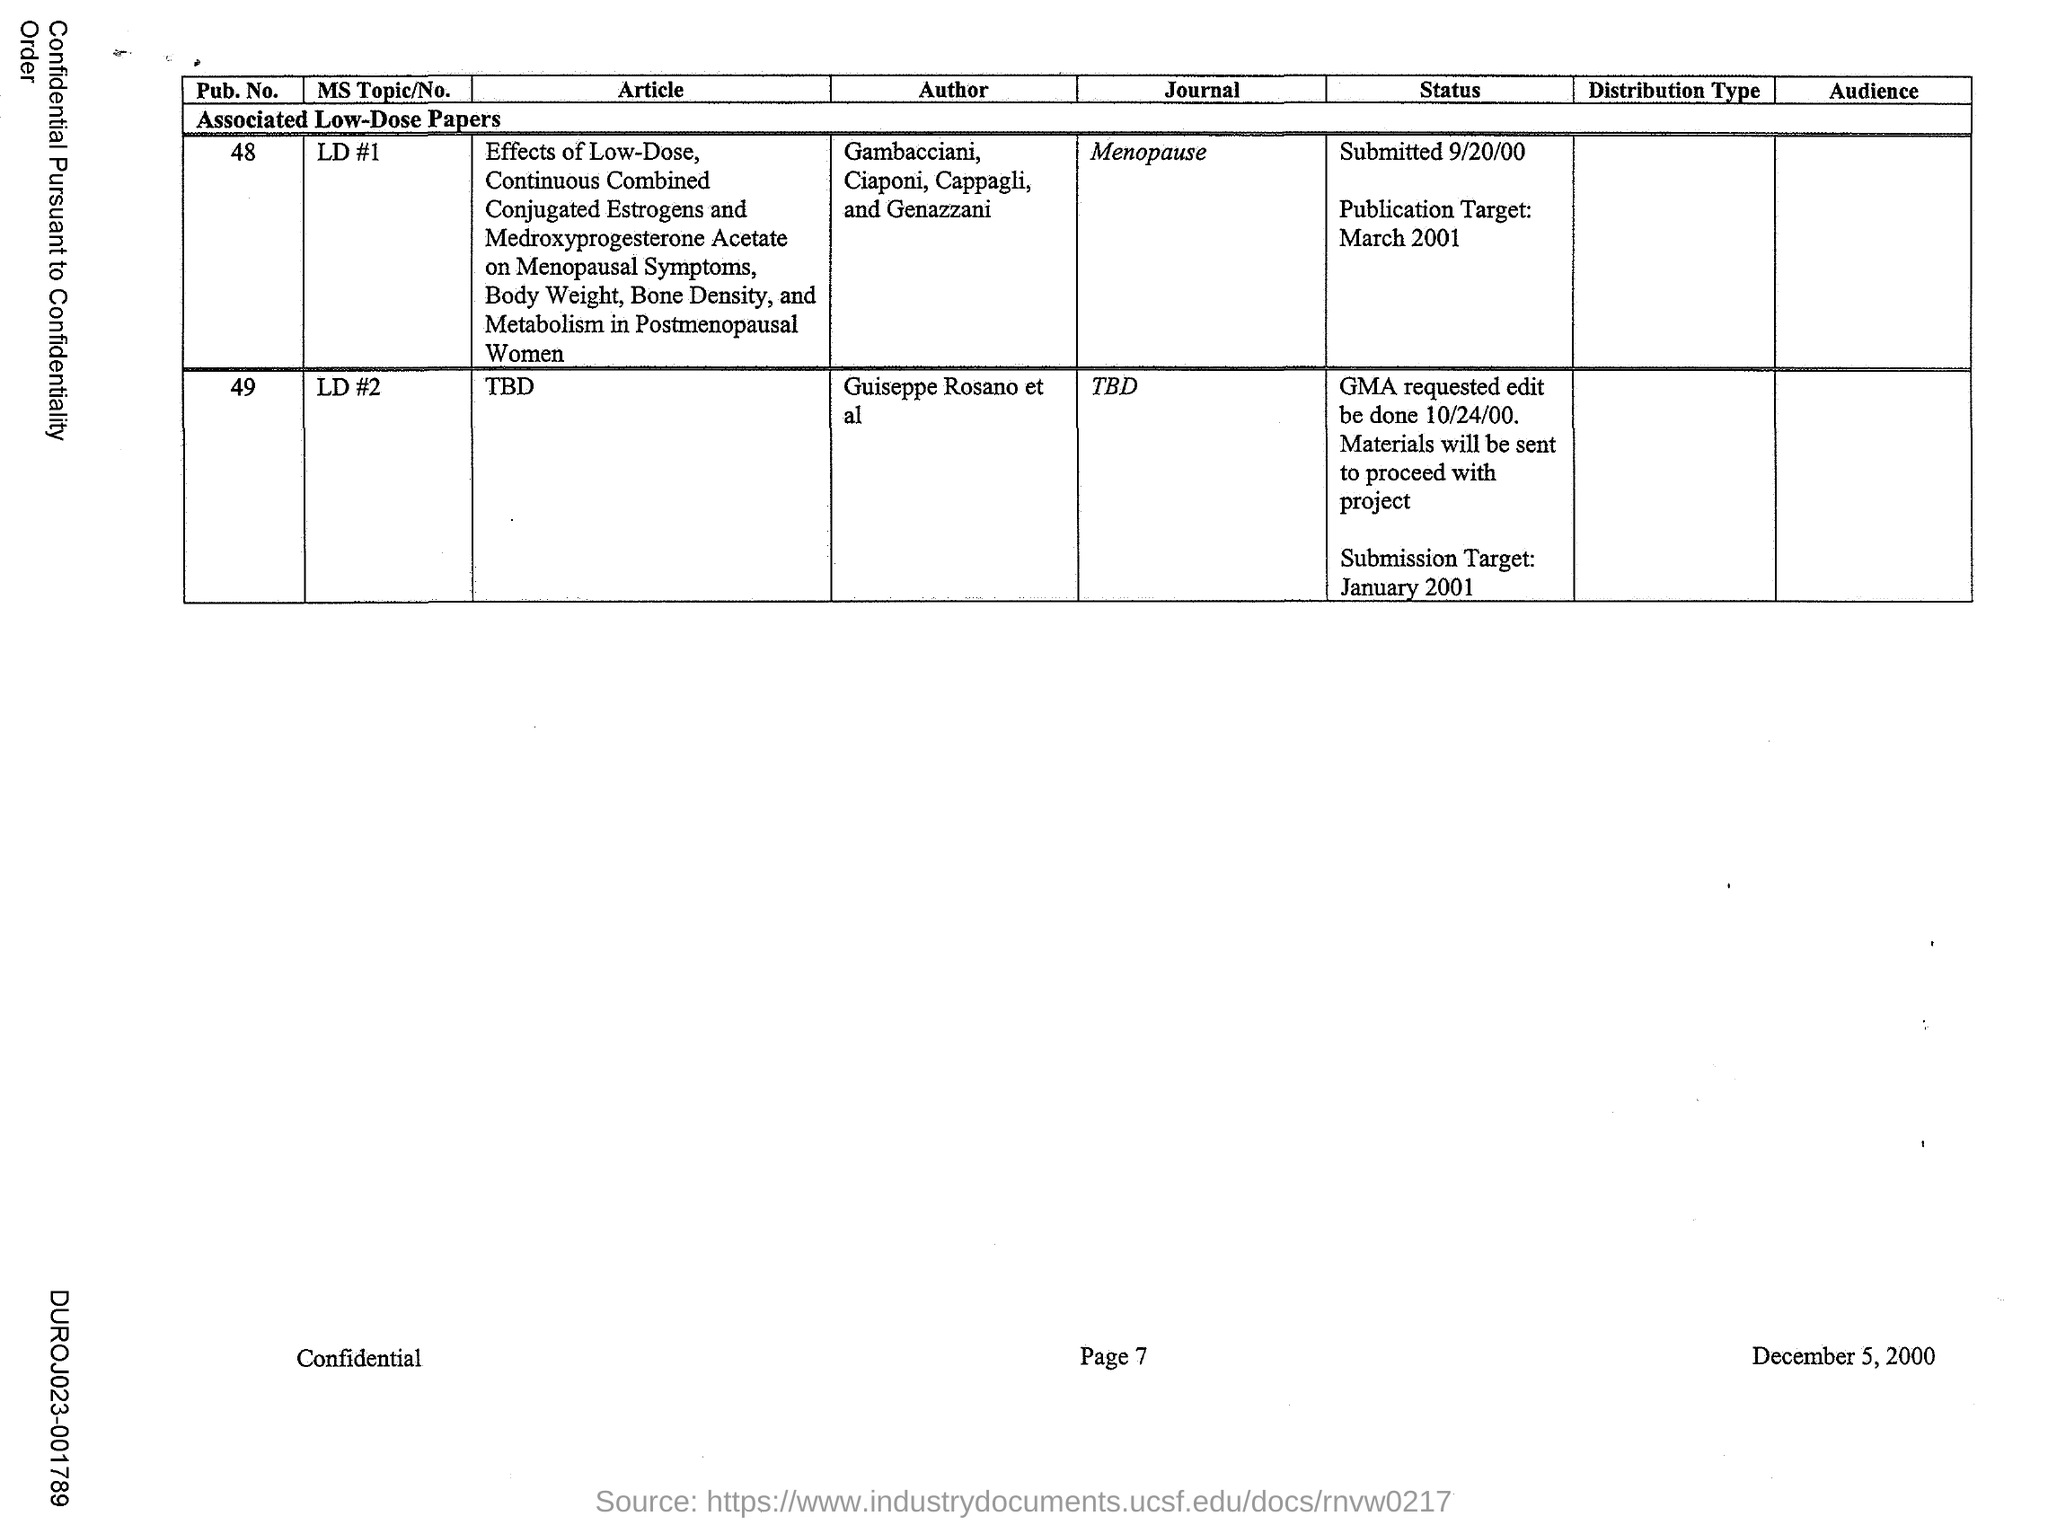Which is the Journal associated with Pub No. 48?
Your answer should be very brief. Menopause. Which is the Journal associated with Pub No. 49?
Keep it short and to the point. TBD. 